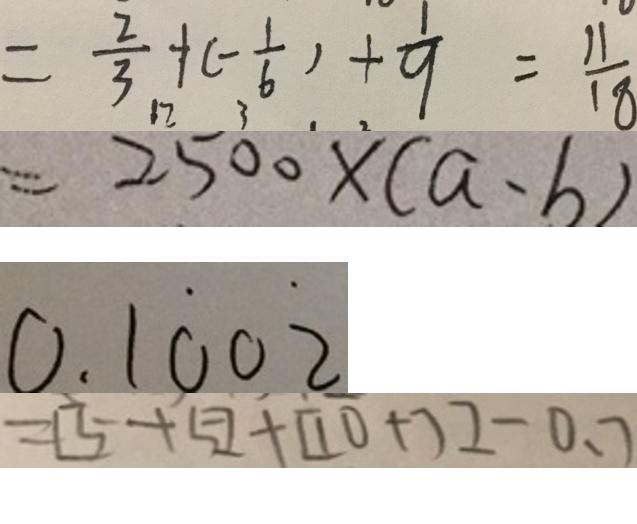<formula> <loc_0><loc_0><loc_500><loc_500>= \frac { 2 } { 3 } + ( - \frac { 1 } { 6 } ) + \frac { 1 } { 9 } = \frac { 1 1 } { 1 8 } 
 = 2 5 0 0 \times ( a - b ) 
 0 . 1 \dot { 0 } 0 \dot { 2 } 
 = [ 5 + 5 ] + [ 1 0 + 7 ] - 0 . 7</formula> 